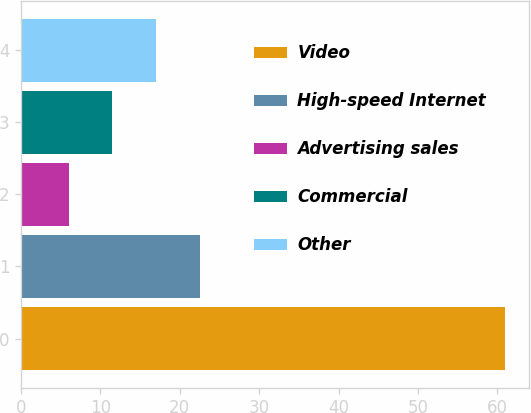<chart> <loc_0><loc_0><loc_500><loc_500><bar_chart><fcel>Video<fcel>High-speed Internet<fcel>Advertising sales<fcel>Commercial<fcel>Other<nl><fcel>61<fcel>22.5<fcel>6<fcel>11.5<fcel>17<nl></chart> 